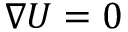Convert formula to latex. <formula><loc_0><loc_0><loc_500><loc_500>\nabla U = 0</formula> 